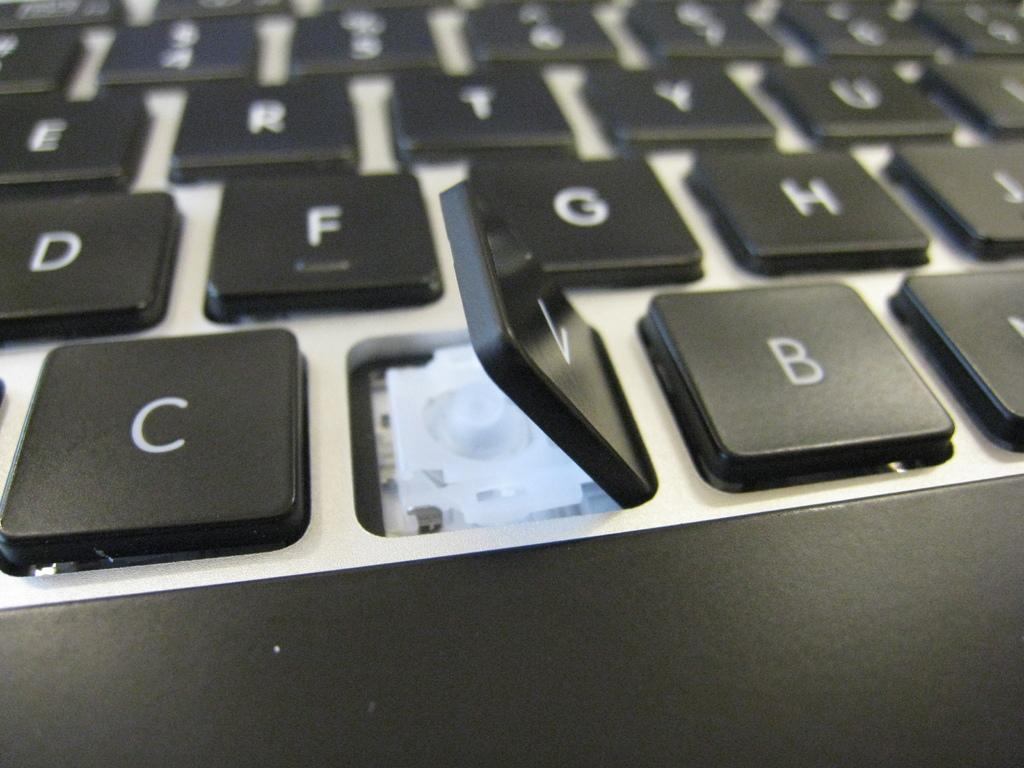<image>
Summarize the visual content of the image. A black keyboard with the letter V popped up. 